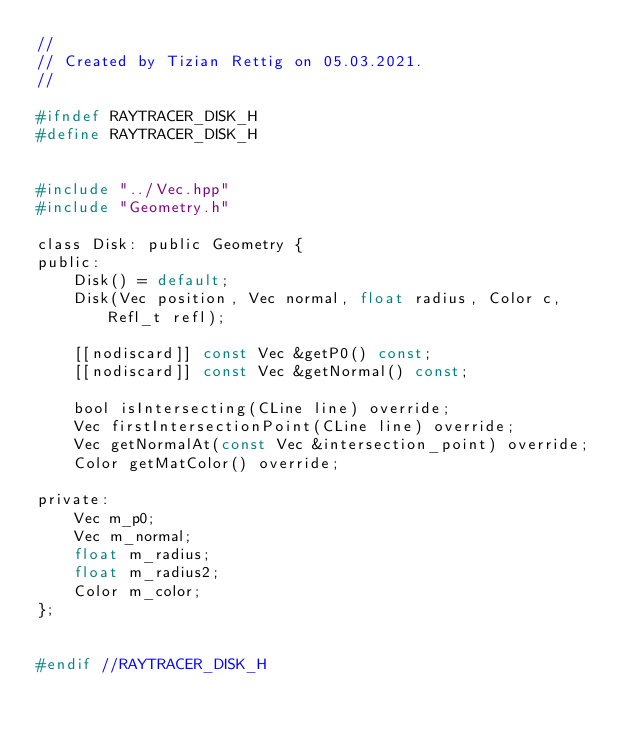<code> <loc_0><loc_0><loc_500><loc_500><_C_>//
// Created by Tizian Rettig on 05.03.2021.
//

#ifndef RAYTRACER_DISK_H
#define RAYTRACER_DISK_H


#include "../Vec.hpp"
#include "Geometry.h"

class Disk: public Geometry {
public:
    Disk() = default;
    Disk(Vec position, Vec normal, float radius, Color c, Refl_t refl);

    [[nodiscard]] const Vec &getP0() const;
    [[nodiscard]] const Vec &getNormal() const;

    bool isIntersecting(CLine line) override;
    Vec firstIntersectionPoint(CLine line) override;
    Vec getNormalAt(const Vec &intersection_point) override;
    Color getMatColor() override;

private:
    Vec m_p0;
    Vec m_normal;
    float m_radius;
    float m_radius2;
    Color m_color;
};


#endif //RAYTRACER_DISK_H
</code> 